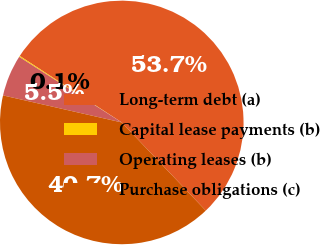<chart> <loc_0><loc_0><loc_500><loc_500><pie_chart><fcel>Long-term debt (a)<fcel>Capital lease payments (b)<fcel>Operating leases (b)<fcel>Purchase obligations (c)<nl><fcel>53.69%<fcel>0.14%<fcel>5.49%<fcel>40.68%<nl></chart> 